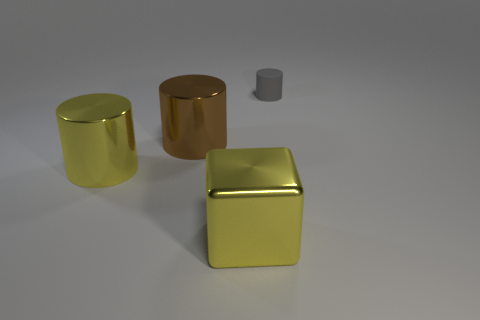Considering the arrangement of these objects, what could be a potential use for them in this setting? The arrangement of these objects, which resemble geometric shapes with a metallic finish, suggests they could be part of a display for aesthetic or educational purposes. They might be used to demonstrate properties of light reflection and refraction, or simply as a visual composition in a contemporary art installation. 